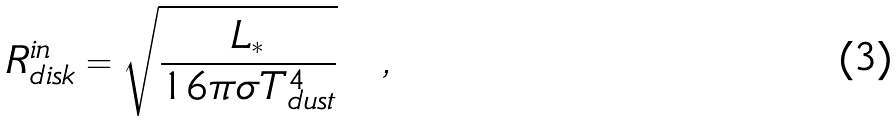Convert formula to latex. <formula><loc_0><loc_0><loc_500><loc_500>R _ { d i s k } ^ { i n } = \sqrt { \frac { L _ { * } } { 1 6 \pi \sigma T _ { d u s t } ^ { 4 } } } \quad ,</formula> 